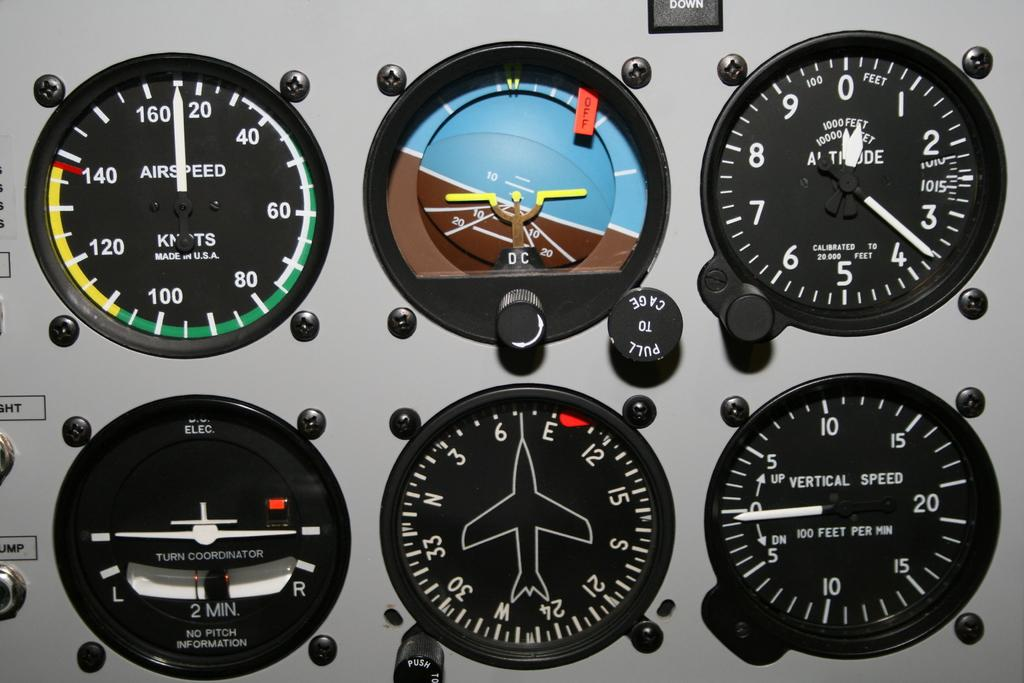What device is present in the picture? There is a speedometer in the picture. What information does the speedometer provide? The speedometer has a numerical reading. What color are the indicators on the speedometer? The indicators on the speedometer are in white color. What else can be seen in the picture besides the speedometer? There are nuts visible in the picture. Can you hear the horse neighing in the picture? There is no horse present in the picture, so it is not possible to hear any neighing. 